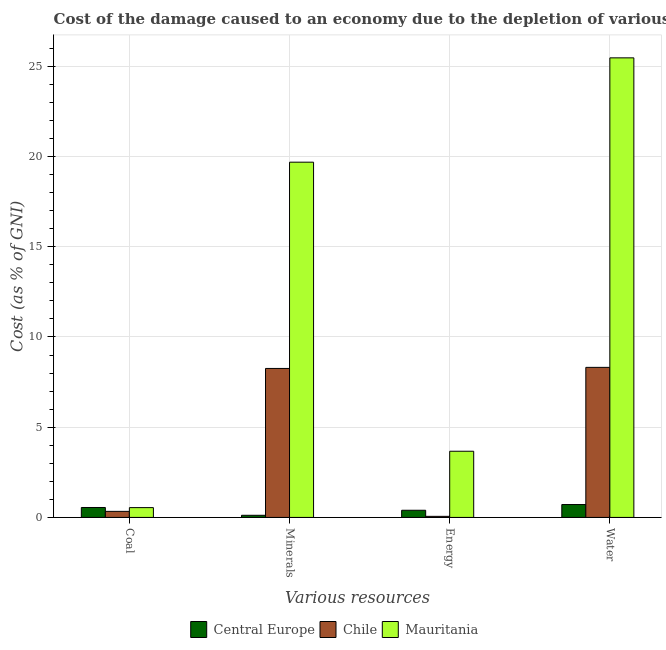How many different coloured bars are there?
Make the answer very short. 3. How many groups of bars are there?
Give a very brief answer. 4. Are the number of bars on each tick of the X-axis equal?
Your answer should be very brief. Yes. What is the label of the 1st group of bars from the left?
Keep it short and to the point. Coal. What is the cost of damage due to depletion of energy in Chile?
Offer a very short reply. 0.06. Across all countries, what is the maximum cost of damage due to depletion of coal?
Make the answer very short. 0.55. Across all countries, what is the minimum cost of damage due to depletion of energy?
Your answer should be compact. 0.06. In which country was the cost of damage due to depletion of energy maximum?
Your answer should be compact. Mauritania. What is the total cost of damage due to depletion of water in the graph?
Your answer should be compact. 34.5. What is the difference between the cost of damage due to depletion of energy in Central Europe and that in Chile?
Your answer should be compact. 0.34. What is the difference between the cost of damage due to depletion of minerals in Central Europe and the cost of damage due to depletion of energy in Chile?
Provide a succinct answer. 0.06. What is the average cost of damage due to depletion of energy per country?
Provide a succinct answer. 1.38. What is the difference between the cost of damage due to depletion of coal and cost of damage due to depletion of energy in Chile?
Make the answer very short. 0.28. What is the ratio of the cost of damage due to depletion of minerals in Chile to that in Central Europe?
Ensure brevity in your answer.  69.89. Is the difference between the cost of damage due to depletion of minerals in Central Europe and Chile greater than the difference between the cost of damage due to depletion of energy in Central Europe and Chile?
Offer a very short reply. No. What is the difference between the highest and the second highest cost of damage due to depletion of coal?
Provide a succinct answer. 0.01. What is the difference between the highest and the lowest cost of damage due to depletion of minerals?
Offer a very short reply. 19.57. In how many countries, is the cost of damage due to depletion of coal greater than the average cost of damage due to depletion of coal taken over all countries?
Offer a terse response. 2. Does the graph contain grids?
Ensure brevity in your answer.  Yes. Where does the legend appear in the graph?
Provide a succinct answer. Bottom center. How many legend labels are there?
Your answer should be very brief. 3. How are the legend labels stacked?
Provide a succinct answer. Horizontal. What is the title of the graph?
Your answer should be compact. Cost of the damage caused to an economy due to the depletion of various resources in 2013 . What is the label or title of the X-axis?
Keep it short and to the point. Various resources. What is the label or title of the Y-axis?
Your answer should be very brief. Cost (as % of GNI). What is the Cost (as % of GNI) of Central Europe in Coal?
Your response must be concise. 0.55. What is the Cost (as % of GNI) of Chile in Coal?
Your answer should be compact. 0.34. What is the Cost (as % of GNI) in Mauritania in Coal?
Keep it short and to the point. 0.54. What is the Cost (as % of GNI) of Central Europe in Minerals?
Give a very brief answer. 0.12. What is the Cost (as % of GNI) in Chile in Minerals?
Offer a very short reply. 8.26. What is the Cost (as % of GNI) in Mauritania in Minerals?
Make the answer very short. 19.69. What is the Cost (as % of GNI) of Central Europe in Energy?
Offer a very short reply. 0.4. What is the Cost (as % of GNI) in Chile in Energy?
Your response must be concise. 0.06. What is the Cost (as % of GNI) of Mauritania in Energy?
Offer a terse response. 3.67. What is the Cost (as % of GNI) of Central Europe in Water?
Provide a succinct answer. 0.71. What is the Cost (as % of GNI) in Chile in Water?
Ensure brevity in your answer.  8.32. What is the Cost (as % of GNI) in Mauritania in Water?
Ensure brevity in your answer.  25.47. Across all Various resources, what is the maximum Cost (as % of GNI) of Central Europe?
Your answer should be very brief. 0.71. Across all Various resources, what is the maximum Cost (as % of GNI) in Chile?
Make the answer very short. 8.32. Across all Various resources, what is the maximum Cost (as % of GNI) of Mauritania?
Provide a short and direct response. 25.47. Across all Various resources, what is the minimum Cost (as % of GNI) in Central Europe?
Your answer should be compact. 0.12. Across all Various resources, what is the minimum Cost (as % of GNI) in Chile?
Give a very brief answer. 0.06. Across all Various resources, what is the minimum Cost (as % of GNI) in Mauritania?
Ensure brevity in your answer.  0.54. What is the total Cost (as % of GNI) in Central Europe in the graph?
Provide a short and direct response. 1.78. What is the total Cost (as % of GNI) in Chile in the graph?
Your answer should be very brief. 16.97. What is the total Cost (as % of GNI) in Mauritania in the graph?
Keep it short and to the point. 49.37. What is the difference between the Cost (as % of GNI) in Central Europe in Coal and that in Minerals?
Your response must be concise. 0.43. What is the difference between the Cost (as % of GNI) in Chile in Coal and that in Minerals?
Your answer should be very brief. -7.92. What is the difference between the Cost (as % of GNI) of Mauritania in Coal and that in Minerals?
Keep it short and to the point. -19.14. What is the difference between the Cost (as % of GNI) of Central Europe in Coal and that in Energy?
Provide a succinct answer. 0.15. What is the difference between the Cost (as % of GNI) of Chile in Coal and that in Energy?
Offer a very short reply. 0.28. What is the difference between the Cost (as % of GNI) of Mauritania in Coal and that in Energy?
Your response must be concise. -3.12. What is the difference between the Cost (as % of GNI) in Central Europe in Coal and that in Water?
Offer a very short reply. -0.16. What is the difference between the Cost (as % of GNI) of Chile in Coal and that in Water?
Provide a succinct answer. -7.98. What is the difference between the Cost (as % of GNI) in Mauritania in Coal and that in Water?
Your answer should be very brief. -24.93. What is the difference between the Cost (as % of GNI) of Central Europe in Minerals and that in Energy?
Offer a very short reply. -0.28. What is the difference between the Cost (as % of GNI) in Chile in Minerals and that in Energy?
Your answer should be very brief. 8.2. What is the difference between the Cost (as % of GNI) in Mauritania in Minerals and that in Energy?
Your answer should be very brief. 16.02. What is the difference between the Cost (as % of GNI) in Central Europe in Minerals and that in Water?
Offer a terse response. -0.6. What is the difference between the Cost (as % of GNI) in Chile in Minerals and that in Water?
Your response must be concise. -0.06. What is the difference between the Cost (as % of GNI) of Mauritania in Minerals and that in Water?
Your answer should be compact. -5.78. What is the difference between the Cost (as % of GNI) in Central Europe in Energy and that in Water?
Ensure brevity in your answer.  -0.32. What is the difference between the Cost (as % of GNI) of Chile in Energy and that in Water?
Your answer should be compact. -8.26. What is the difference between the Cost (as % of GNI) in Mauritania in Energy and that in Water?
Keep it short and to the point. -21.8. What is the difference between the Cost (as % of GNI) in Central Europe in Coal and the Cost (as % of GNI) in Chile in Minerals?
Your answer should be very brief. -7.71. What is the difference between the Cost (as % of GNI) of Central Europe in Coal and the Cost (as % of GNI) of Mauritania in Minerals?
Provide a short and direct response. -19.14. What is the difference between the Cost (as % of GNI) of Chile in Coal and the Cost (as % of GNI) of Mauritania in Minerals?
Make the answer very short. -19.35. What is the difference between the Cost (as % of GNI) of Central Europe in Coal and the Cost (as % of GNI) of Chile in Energy?
Your response must be concise. 0.49. What is the difference between the Cost (as % of GNI) in Central Europe in Coal and the Cost (as % of GNI) in Mauritania in Energy?
Your answer should be compact. -3.12. What is the difference between the Cost (as % of GNI) in Chile in Coal and the Cost (as % of GNI) in Mauritania in Energy?
Offer a very short reply. -3.33. What is the difference between the Cost (as % of GNI) in Central Europe in Coal and the Cost (as % of GNI) in Chile in Water?
Ensure brevity in your answer.  -7.77. What is the difference between the Cost (as % of GNI) in Central Europe in Coal and the Cost (as % of GNI) in Mauritania in Water?
Provide a short and direct response. -24.92. What is the difference between the Cost (as % of GNI) in Chile in Coal and the Cost (as % of GNI) in Mauritania in Water?
Your answer should be compact. -25.13. What is the difference between the Cost (as % of GNI) in Central Europe in Minerals and the Cost (as % of GNI) in Chile in Energy?
Your answer should be compact. 0.06. What is the difference between the Cost (as % of GNI) of Central Europe in Minerals and the Cost (as % of GNI) of Mauritania in Energy?
Make the answer very short. -3.55. What is the difference between the Cost (as % of GNI) of Chile in Minerals and the Cost (as % of GNI) of Mauritania in Energy?
Ensure brevity in your answer.  4.59. What is the difference between the Cost (as % of GNI) of Central Europe in Minerals and the Cost (as % of GNI) of Chile in Water?
Provide a short and direct response. -8.2. What is the difference between the Cost (as % of GNI) in Central Europe in Minerals and the Cost (as % of GNI) in Mauritania in Water?
Ensure brevity in your answer.  -25.35. What is the difference between the Cost (as % of GNI) of Chile in Minerals and the Cost (as % of GNI) of Mauritania in Water?
Make the answer very short. -17.21. What is the difference between the Cost (as % of GNI) of Central Europe in Energy and the Cost (as % of GNI) of Chile in Water?
Offer a very short reply. -7.92. What is the difference between the Cost (as % of GNI) in Central Europe in Energy and the Cost (as % of GNI) in Mauritania in Water?
Provide a succinct answer. -25.07. What is the difference between the Cost (as % of GNI) in Chile in Energy and the Cost (as % of GNI) in Mauritania in Water?
Offer a very short reply. -25.41. What is the average Cost (as % of GNI) in Central Europe per Various resources?
Your answer should be very brief. 0.45. What is the average Cost (as % of GNI) in Chile per Various resources?
Provide a short and direct response. 4.24. What is the average Cost (as % of GNI) of Mauritania per Various resources?
Make the answer very short. 12.34. What is the difference between the Cost (as % of GNI) in Central Europe and Cost (as % of GNI) in Chile in Coal?
Your response must be concise. 0.22. What is the difference between the Cost (as % of GNI) of Central Europe and Cost (as % of GNI) of Mauritania in Coal?
Keep it short and to the point. 0.01. What is the difference between the Cost (as % of GNI) in Chile and Cost (as % of GNI) in Mauritania in Coal?
Ensure brevity in your answer.  -0.21. What is the difference between the Cost (as % of GNI) of Central Europe and Cost (as % of GNI) of Chile in Minerals?
Keep it short and to the point. -8.14. What is the difference between the Cost (as % of GNI) of Central Europe and Cost (as % of GNI) of Mauritania in Minerals?
Make the answer very short. -19.57. What is the difference between the Cost (as % of GNI) of Chile and Cost (as % of GNI) of Mauritania in Minerals?
Your answer should be very brief. -11.43. What is the difference between the Cost (as % of GNI) of Central Europe and Cost (as % of GNI) of Chile in Energy?
Offer a terse response. 0.34. What is the difference between the Cost (as % of GNI) of Central Europe and Cost (as % of GNI) of Mauritania in Energy?
Your response must be concise. -3.27. What is the difference between the Cost (as % of GNI) of Chile and Cost (as % of GNI) of Mauritania in Energy?
Your answer should be very brief. -3.61. What is the difference between the Cost (as % of GNI) of Central Europe and Cost (as % of GNI) of Chile in Water?
Offer a very short reply. -7.6. What is the difference between the Cost (as % of GNI) in Central Europe and Cost (as % of GNI) in Mauritania in Water?
Offer a terse response. -24.76. What is the difference between the Cost (as % of GNI) in Chile and Cost (as % of GNI) in Mauritania in Water?
Keep it short and to the point. -17.15. What is the ratio of the Cost (as % of GNI) of Central Europe in Coal to that in Minerals?
Ensure brevity in your answer.  4.66. What is the ratio of the Cost (as % of GNI) in Chile in Coal to that in Minerals?
Your answer should be compact. 0.04. What is the ratio of the Cost (as % of GNI) in Mauritania in Coal to that in Minerals?
Give a very brief answer. 0.03. What is the ratio of the Cost (as % of GNI) in Central Europe in Coal to that in Energy?
Provide a succinct answer. 1.39. What is the ratio of the Cost (as % of GNI) of Chile in Coal to that in Energy?
Give a very brief answer. 5.63. What is the ratio of the Cost (as % of GNI) in Mauritania in Coal to that in Energy?
Your answer should be compact. 0.15. What is the ratio of the Cost (as % of GNI) of Central Europe in Coal to that in Water?
Give a very brief answer. 0.77. What is the ratio of the Cost (as % of GNI) in Chile in Coal to that in Water?
Your response must be concise. 0.04. What is the ratio of the Cost (as % of GNI) in Mauritania in Coal to that in Water?
Offer a terse response. 0.02. What is the ratio of the Cost (as % of GNI) of Central Europe in Minerals to that in Energy?
Your answer should be compact. 0.3. What is the ratio of the Cost (as % of GNI) in Chile in Minerals to that in Energy?
Ensure brevity in your answer.  138.46. What is the ratio of the Cost (as % of GNI) in Mauritania in Minerals to that in Energy?
Ensure brevity in your answer.  5.37. What is the ratio of the Cost (as % of GNI) of Central Europe in Minerals to that in Water?
Your answer should be compact. 0.17. What is the ratio of the Cost (as % of GNI) of Chile in Minerals to that in Water?
Offer a very short reply. 0.99. What is the ratio of the Cost (as % of GNI) in Mauritania in Minerals to that in Water?
Offer a very short reply. 0.77. What is the ratio of the Cost (as % of GNI) of Central Europe in Energy to that in Water?
Your answer should be compact. 0.56. What is the ratio of the Cost (as % of GNI) in Chile in Energy to that in Water?
Ensure brevity in your answer.  0.01. What is the ratio of the Cost (as % of GNI) in Mauritania in Energy to that in Water?
Provide a succinct answer. 0.14. What is the difference between the highest and the second highest Cost (as % of GNI) of Central Europe?
Offer a very short reply. 0.16. What is the difference between the highest and the second highest Cost (as % of GNI) in Chile?
Offer a terse response. 0.06. What is the difference between the highest and the second highest Cost (as % of GNI) of Mauritania?
Your answer should be compact. 5.78. What is the difference between the highest and the lowest Cost (as % of GNI) of Central Europe?
Offer a terse response. 0.6. What is the difference between the highest and the lowest Cost (as % of GNI) of Chile?
Provide a succinct answer. 8.26. What is the difference between the highest and the lowest Cost (as % of GNI) in Mauritania?
Offer a terse response. 24.93. 